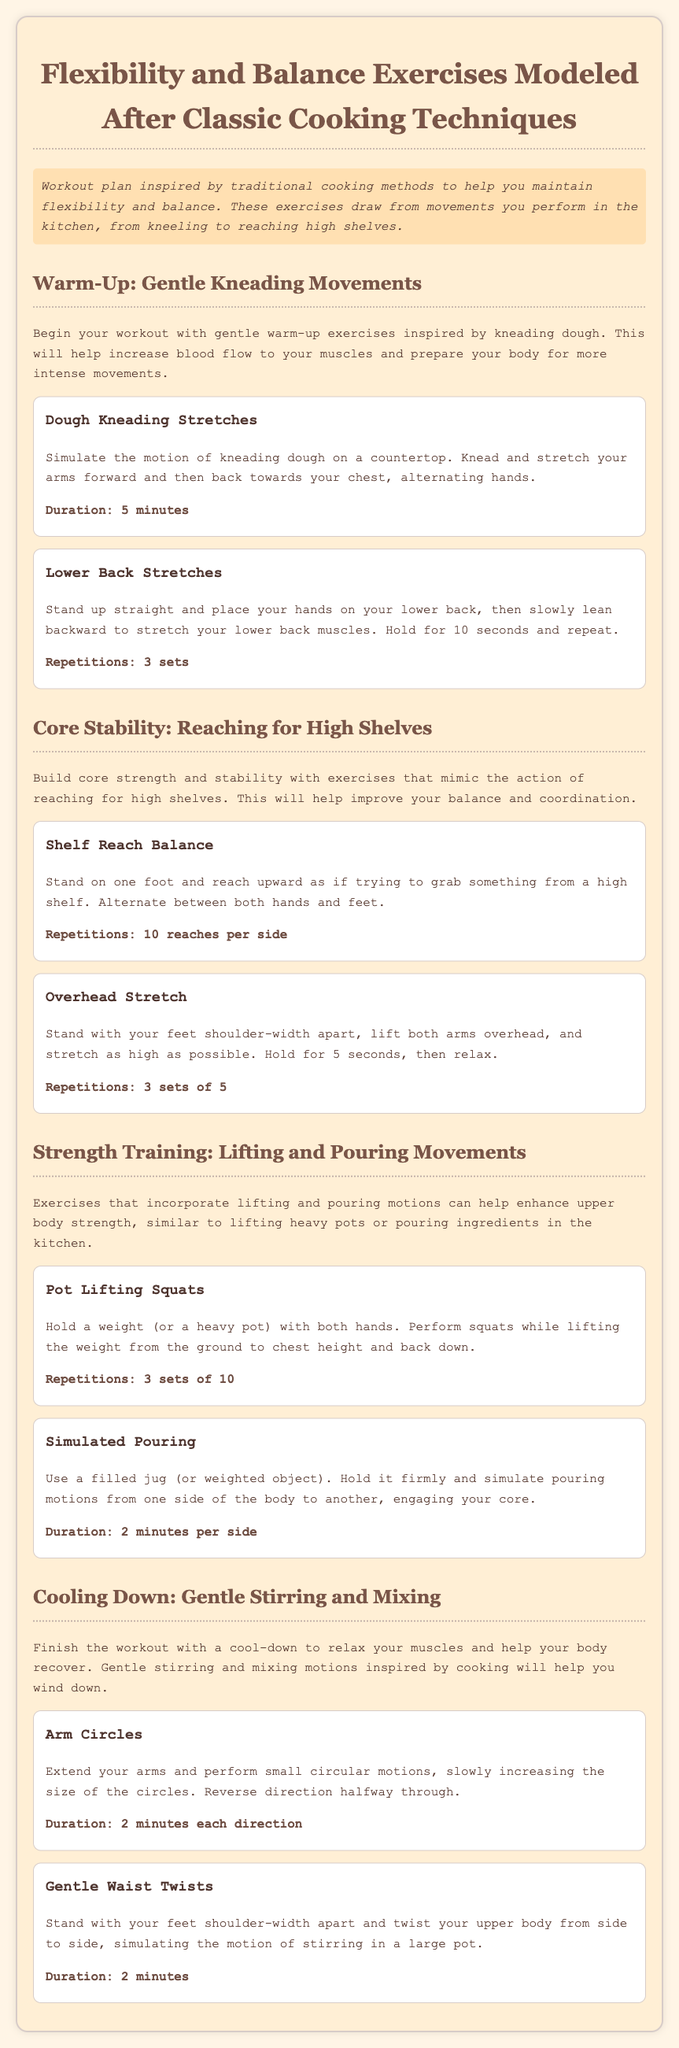What is the title of the workout plan? The title is prominently displayed at the top of the document.
Answer: Flexibility and Balance Exercises Modeled After Classic Cooking Techniques How long should the Dough Kneading Stretches be performed? The duration is specified after the description of the exercise.
Answer: 5 minutes How many repetitions are suggested for Shelf Reach Balance? The document states the suggested repetitions for this exercise specifically.
Answer: 10 reaches per side What exercise is suggested to cool down? The document lists exercises under the cooling down section.
Answer: Arm Circles What is the duration for the Gentle Waist Twists exercise? The document provides specific duration for this exercise in the cooling down section.
Answer: 2 minutes 